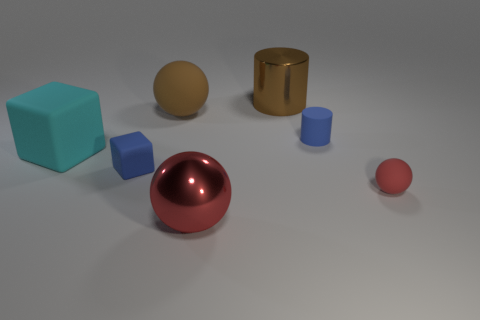There is a metal cylinder that is to the right of the big rubber thing that is in front of the large matte sphere; what size is it?
Your response must be concise. Large. Is the number of tiny balls greater than the number of blue shiny things?
Give a very brief answer. Yes. Does the ball that is on the right side of the large brown shiny object have the same color as the metal object that is in front of the brown sphere?
Ensure brevity in your answer.  Yes. Are there any small objects to the right of the tiny blue rubber object behind the blue rubber cube?
Provide a short and direct response. Yes. Are there fewer small things that are behind the large cyan thing than matte objects that are on the left side of the large brown shiny cylinder?
Your answer should be very brief. Yes. Do the tiny blue object right of the large cylinder and the big ball that is in front of the large matte ball have the same material?
Provide a short and direct response. No. What number of small things are either matte cylinders or blue blocks?
Offer a very short reply. 2. There is a blue thing that is made of the same material as the tiny blue cylinder; what shape is it?
Provide a short and direct response. Cube. Is the number of small blue matte blocks behind the large brown cylinder less than the number of small shiny objects?
Offer a terse response. No. Is the shape of the red shiny thing the same as the tiny red thing?
Ensure brevity in your answer.  Yes. 